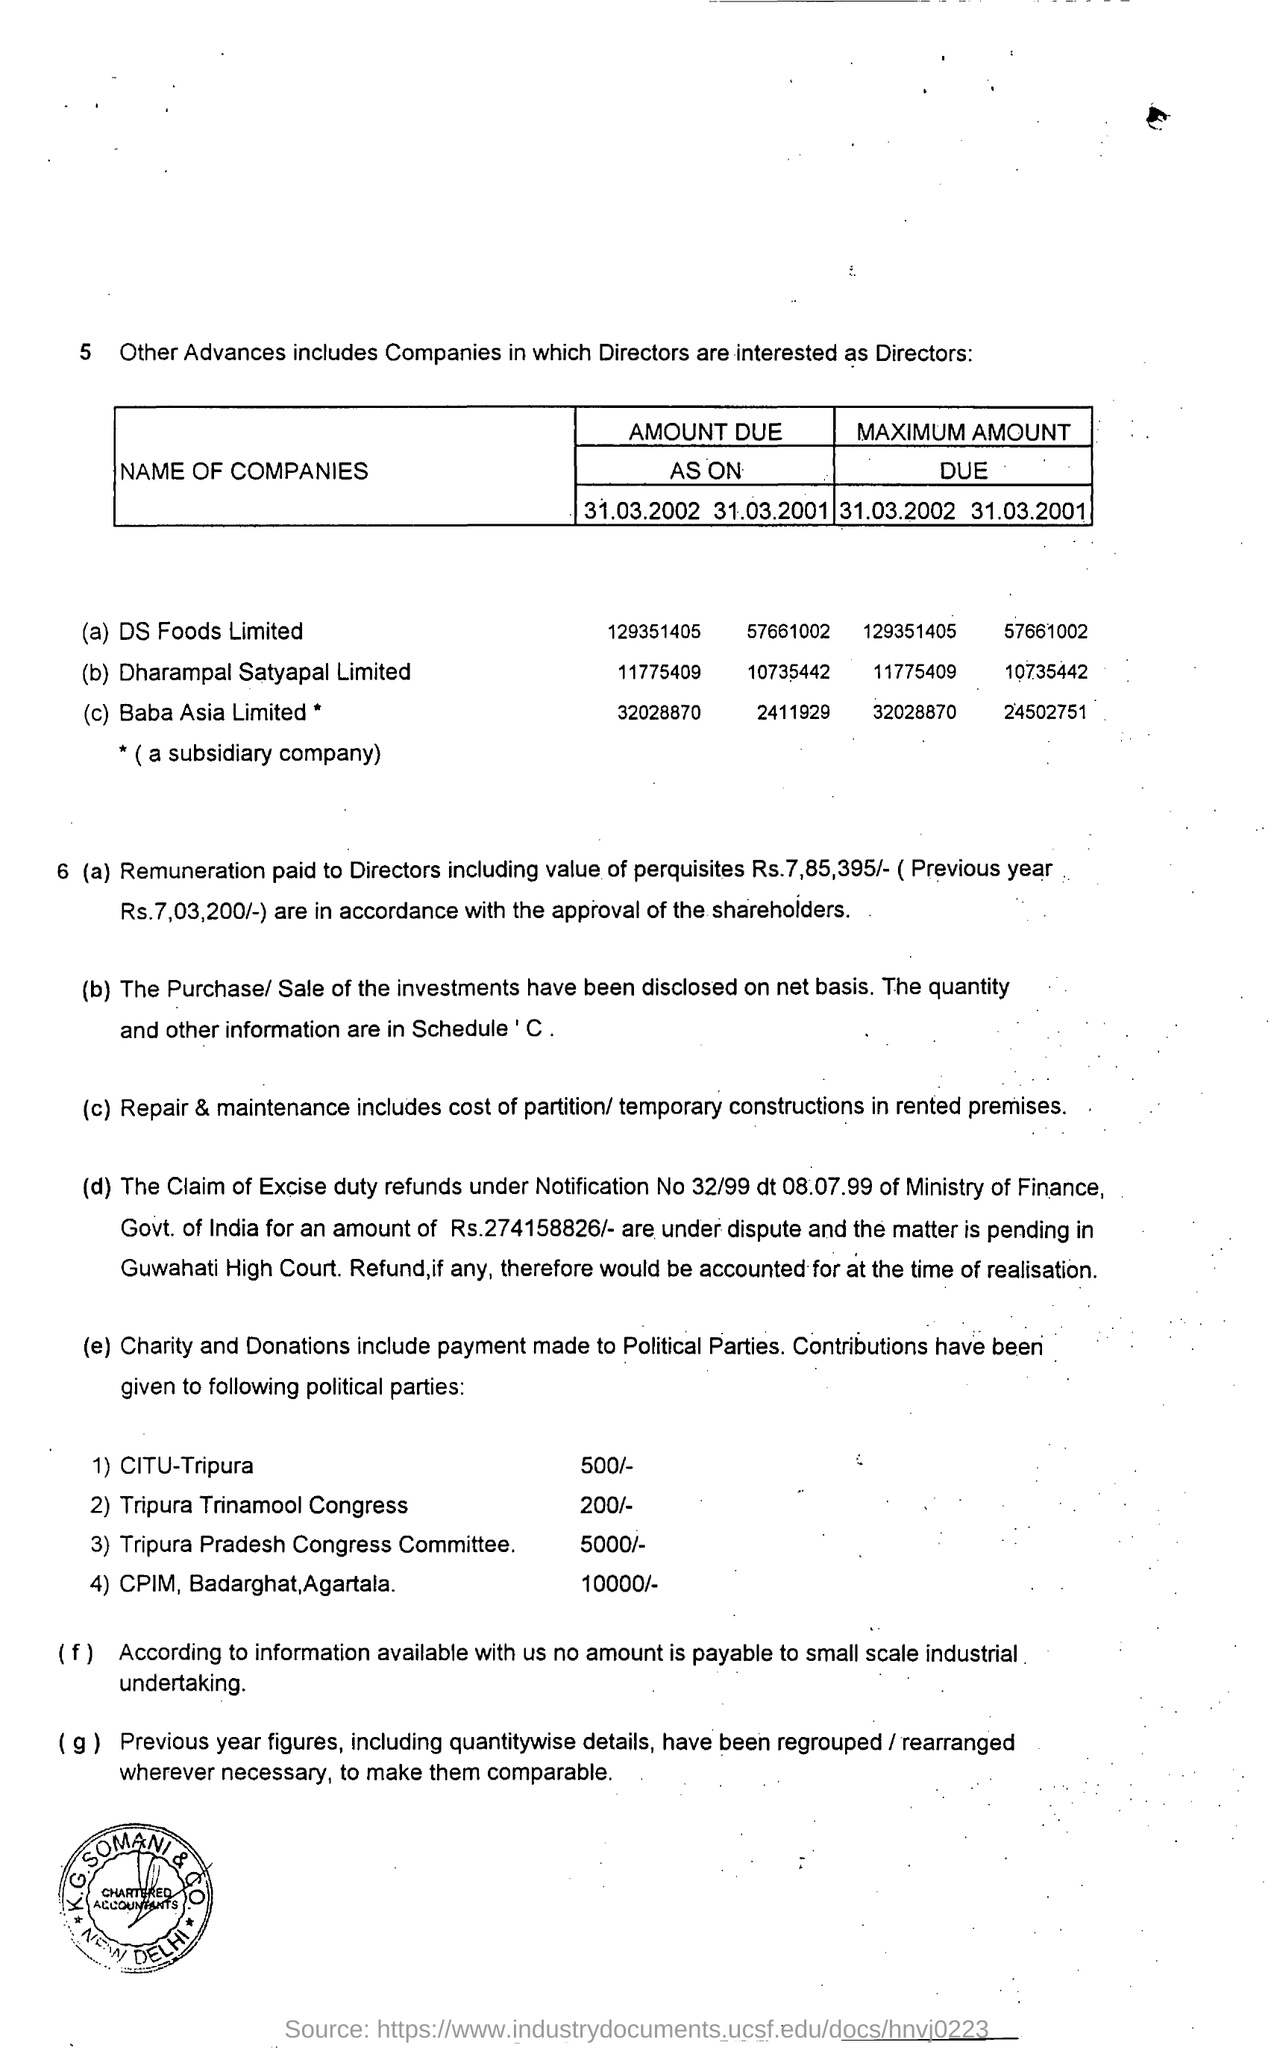Highlight a few significant elements in this photo. The directors were paid a total amount of 7,85,395, including the value of perquisites. The amount contributed to the Tripura Trinamool Congress is 200. As of 31.03.2002, the amount due for DS Foods Limited is 129,351,405. The contribution made to the Tripura Pradesh Congress Committee is 5000/-. The amount contributed to CITU-Tripura is 500/-. 